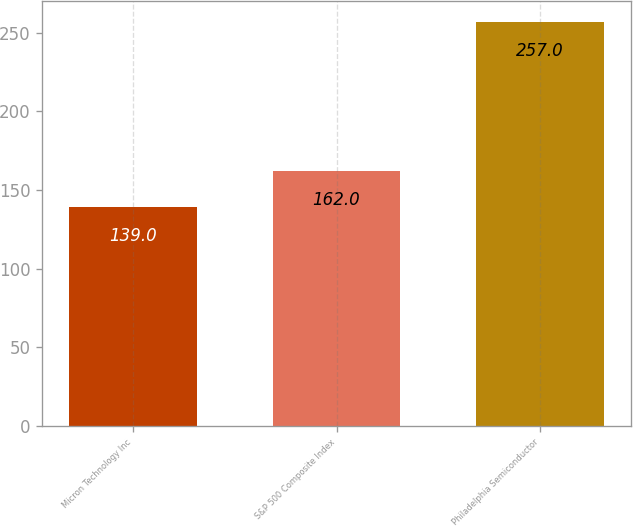Convert chart to OTSL. <chart><loc_0><loc_0><loc_500><loc_500><bar_chart><fcel>Micron Technology Inc<fcel>S&P 500 Composite Index<fcel>Philadelphia Semiconductor<nl><fcel>139<fcel>162<fcel>257<nl></chart> 